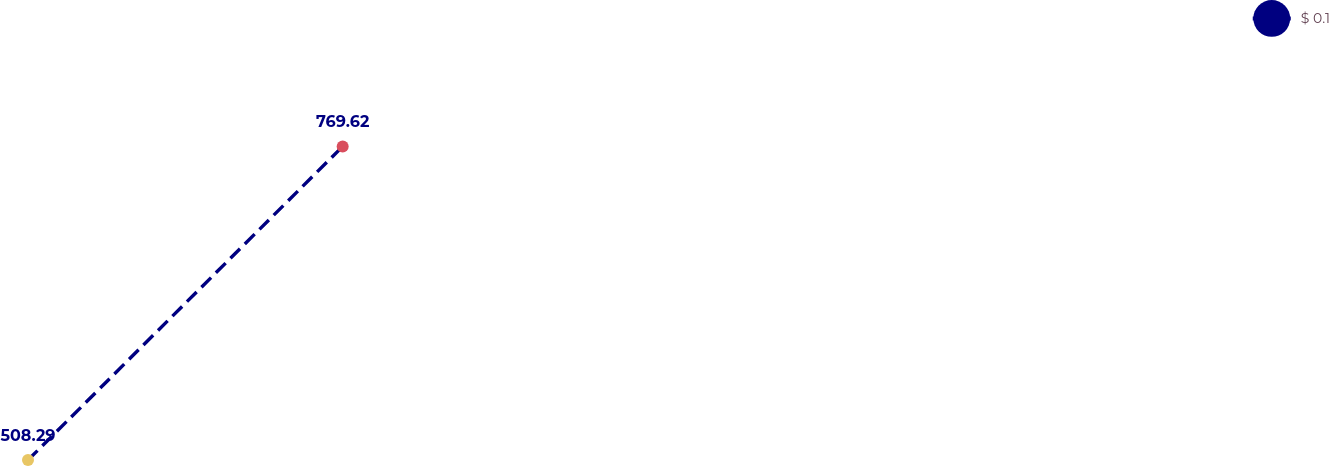<chart> <loc_0><loc_0><loc_500><loc_500><line_chart><ecel><fcel>$ 0.1<nl><fcel>1690.72<fcel>508.29<nl><fcel>1852.31<fcel>769.62<nl><fcel>2285.82<fcel>254.56<nl><fcel>2348.03<fcel>559.8<nl></chart> 